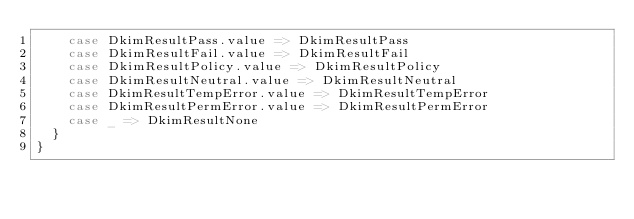Convert code to text. <code><loc_0><loc_0><loc_500><loc_500><_Scala_>    case DkimResultPass.value => DkimResultPass
    case DkimResultFail.value => DkimResultFail
    case DkimResultPolicy.value => DkimResultPolicy
    case DkimResultNeutral.value => DkimResultNeutral
    case DkimResultTempError.value => DkimResultTempError
    case DkimResultPermError.value => DkimResultPermError
    case _ => DkimResultNone
  }
}</code> 